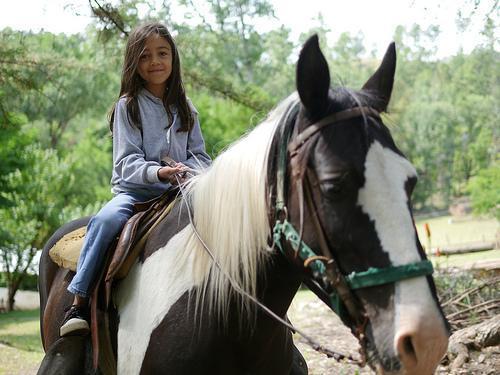How many people are riding a horse?
Give a very brief answer. 1. 